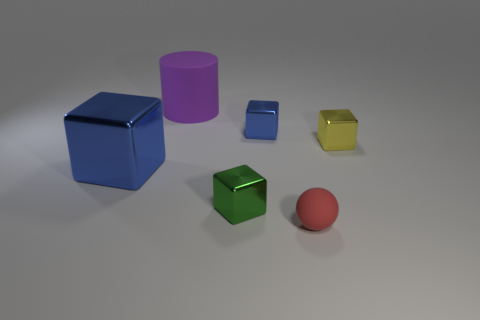There is a metal object that is on the right side of the matte thing on the right side of the large matte cylinder; what number of small things are in front of it?
Ensure brevity in your answer.  2. Is there any other thing of the same color as the large metallic thing?
Make the answer very short. Yes. Does the block behind the yellow object have the same color as the large thing in front of the tiny blue block?
Your answer should be very brief. Yes. Are there more things that are in front of the big blue metal block than spheres that are to the left of the large cylinder?
Provide a short and direct response. Yes. What is the material of the large blue object?
Make the answer very short. Metal. The blue thing that is behind the large thing that is in front of the cube that is to the right of the tiny red sphere is what shape?
Make the answer very short. Cube. How many other things are the same material as the green object?
Your answer should be compact. 3. Is the material of the object that is on the left side of the big purple object the same as the thing that is behind the small blue cube?
Keep it short and to the point. No. How many metallic things are to the left of the small yellow shiny block and right of the large purple rubber object?
Offer a very short reply. 2. Are there any yellow metallic objects of the same shape as the tiny green thing?
Your answer should be very brief. Yes. 